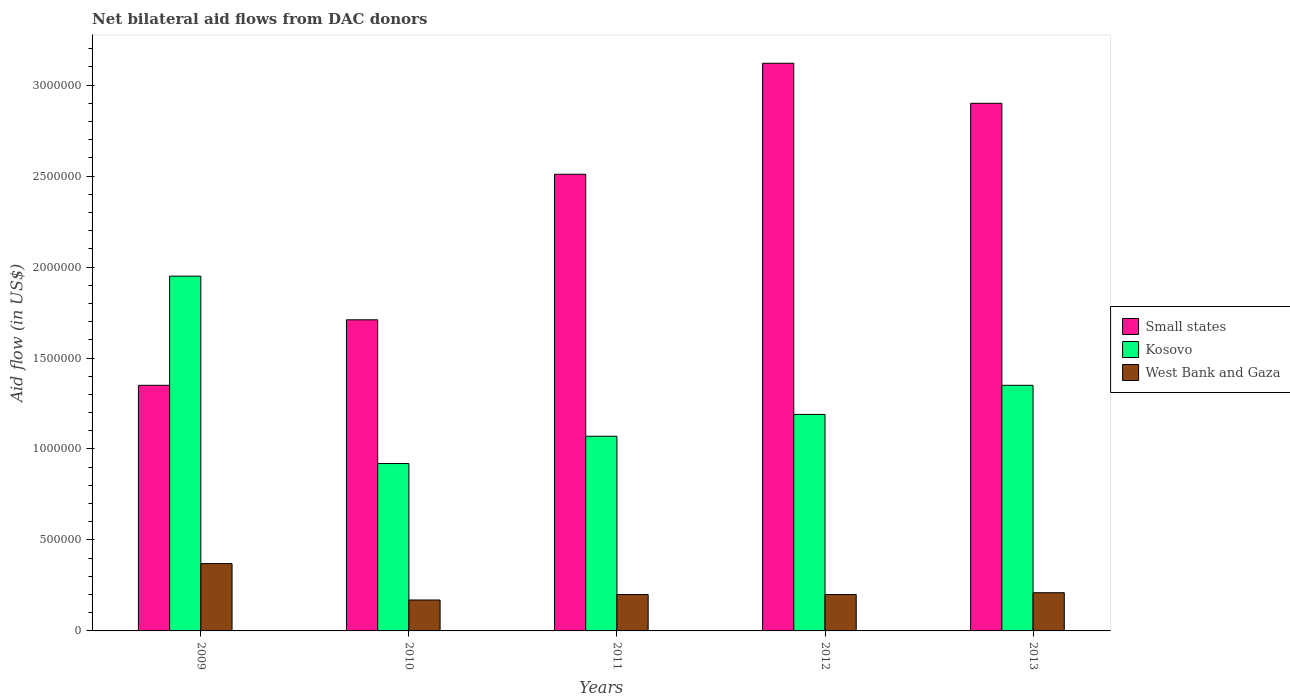How many groups of bars are there?
Your answer should be very brief. 5. Are the number of bars on each tick of the X-axis equal?
Provide a succinct answer. Yes. How many bars are there on the 1st tick from the left?
Offer a very short reply. 3. What is the label of the 5th group of bars from the left?
Provide a short and direct response. 2013. In how many cases, is the number of bars for a given year not equal to the number of legend labels?
Ensure brevity in your answer.  0. What is the net bilateral aid flow in Small states in 2010?
Provide a short and direct response. 1.71e+06. Across all years, what is the maximum net bilateral aid flow in Kosovo?
Give a very brief answer. 1.95e+06. Across all years, what is the minimum net bilateral aid flow in Kosovo?
Make the answer very short. 9.20e+05. What is the total net bilateral aid flow in Kosovo in the graph?
Make the answer very short. 6.48e+06. What is the difference between the net bilateral aid flow in Kosovo in 2012 and that in 2013?
Ensure brevity in your answer.  -1.60e+05. What is the difference between the net bilateral aid flow in Kosovo in 2011 and the net bilateral aid flow in Small states in 2012?
Provide a succinct answer. -2.05e+06. What is the average net bilateral aid flow in Kosovo per year?
Offer a terse response. 1.30e+06. In the year 2011, what is the difference between the net bilateral aid flow in West Bank and Gaza and net bilateral aid flow in Kosovo?
Provide a succinct answer. -8.70e+05. In how many years, is the net bilateral aid flow in West Bank and Gaza greater than 1100000 US$?
Offer a terse response. 0. What is the ratio of the net bilateral aid flow in West Bank and Gaza in 2009 to that in 2010?
Offer a terse response. 2.18. Is the net bilateral aid flow in Small states in 2011 less than that in 2012?
Provide a short and direct response. Yes. Is the difference between the net bilateral aid flow in West Bank and Gaza in 2009 and 2012 greater than the difference between the net bilateral aid flow in Kosovo in 2009 and 2012?
Keep it short and to the point. No. What is the difference between the highest and the second highest net bilateral aid flow in West Bank and Gaza?
Ensure brevity in your answer.  1.60e+05. What is the difference between the highest and the lowest net bilateral aid flow in Small states?
Your response must be concise. 1.77e+06. In how many years, is the net bilateral aid flow in Small states greater than the average net bilateral aid flow in Small states taken over all years?
Give a very brief answer. 3. Is the sum of the net bilateral aid flow in Kosovo in 2009 and 2011 greater than the maximum net bilateral aid flow in Small states across all years?
Offer a very short reply. No. What does the 2nd bar from the left in 2013 represents?
Your answer should be very brief. Kosovo. What does the 3rd bar from the right in 2011 represents?
Provide a short and direct response. Small states. Is it the case that in every year, the sum of the net bilateral aid flow in West Bank and Gaza and net bilateral aid flow in Kosovo is greater than the net bilateral aid flow in Small states?
Provide a short and direct response. No. Are all the bars in the graph horizontal?
Your response must be concise. No. Does the graph contain any zero values?
Provide a succinct answer. No. What is the title of the graph?
Provide a succinct answer. Net bilateral aid flows from DAC donors. What is the label or title of the Y-axis?
Offer a very short reply. Aid flow (in US$). What is the Aid flow (in US$) of Small states in 2009?
Ensure brevity in your answer.  1.35e+06. What is the Aid flow (in US$) of Kosovo in 2009?
Keep it short and to the point. 1.95e+06. What is the Aid flow (in US$) in Small states in 2010?
Provide a short and direct response. 1.71e+06. What is the Aid flow (in US$) in Kosovo in 2010?
Provide a succinct answer. 9.20e+05. What is the Aid flow (in US$) in West Bank and Gaza in 2010?
Give a very brief answer. 1.70e+05. What is the Aid flow (in US$) of Small states in 2011?
Your answer should be compact. 2.51e+06. What is the Aid flow (in US$) in Kosovo in 2011?
Keep it short and to the point. 1.07e+06. What is the Aid flow (in US$) in Small states in 2012?
Give a very brief answer. 3.12e+06. What is the Aid flow (in US$) of Kosovo in 2012?
Keep it short and to the point. 1.19e+06. What is the Aid flow (in US$) in Small states in 2013?
Provide a short and direct response. 2.90e+06. What is the Aid flow (in US$) in Kosovo in 2013?
Your response must be concise. 1.35e+06. Across all years, what is the maximum Aid flow (in US$) in Small states?
Provide a succinct answer. 3.12e+06. Across all years, what is the maximum Aid flow (in US$) in Kosovo?
Provide a short and direct response. 1.95e+06. Across all years, what is the minimum Aid flow (in US$) in Small states?
Keep it short and to the point. 1.35e+06. Across all years, what is the minimum Aid flow (in US$) in Kosovo?
Offer a terse response. 9.20e+05. What is the total Aid flow (in US$) in Small states in the graph?
Provide a short and direct response. 1.16e+07. What is the total Aid flow (in US$) in Kosovo in the graph?
Your answer should be compact. 6.48e+06. What is the total Aid flow (in US$) of West Bank and Gaza in the graph?
Your answer should be compact. 1.15e+06. What is the difference between the Aid flow (in US$) of Small states in 2009 and that in 2010?
Give a very brief answer. -3.60e+05. What is the difference between the Aid flow (in US$) of Kosovo in 2009 and that in 2010?
Ensure brevity in your answer.  1.03e+06. What is the difference between the Aid flow (in US$) of West Bank and Gaza in 2009 and that in 2010?
Ensure brevity in your answer.  2.00e+05. What is the difference between the Aid flow (in US$) of Small states in 2009 and that in 2011?
Give a very brief answer. -1.16e+06. What is the difference between the Aid flow (in US$) in Kosovo in 2009 and that in 2011?
Offer a terse response. 8.80e+05. What is the difference between the Aid flow (in US$) of West Bank and Gaza in 2009 and that in 2011?
Your response must be concise. 1.70e+05. What is the difference between the Aid flow (in US$) in Small states in 2009 and that in 2012?
Your answer should be very brief. -1.77e+06. What is the difference between the Aid flow (in US$) in Kosovo in 2009 and that in 2012?
Your answer should be compact. 7.60e+05. What is the difference between the Aid flow (in US$) of West Bank and Gaza in 2009 and that in 2012?
Provide a succinct answer. 1.70e+05. What is the difference between the Aid flow (in US$) of Small states in 2009 and that in 2013?
Make the answer very short. -1.55e+06. What is the difference between the Aid flow (in US$) of Kosovo in 2009 and that in 2013?
Offer a very short reply. 6.00e+05. What is the difference between the Aid flow (in US$) in West Bank and Gaza in 2009 and that in 2013?
Your response must be concise. 1.60e+05. What is the difference between the Aid flow (in US$) in Small states in 2010 and that in 2011?
Provide a succinct answer. -8.00e+05. What is the difference between the Aid flow (in US$) in West Bank and Gaza in 2010 and that in 2011?
Give a very brief answer. -3.00e+04. What is the difference between the Aid flow (in US$) in Small states in 2010 and that in 2012?
Your answer should be very brief. -1.41e+06. What is the difference between the Aid flow (in US$) of Kosovo in 2010 and that in 2012?
Give a very brief answer. -2.70e+05. What is the difference between the Aid flow (in US$) of West Bank and Gaza in 2010 and that in 2012?
Offer a very short reply. -3.00e+04. What is the difference between the Aid flow (in US$) in Small states in 2010 and that in 2013?
Your answer should be very brief. -1.19e+06. What is the difference between the Aid flow (in US$) of Kosovo in 2010 and that in 2013?
Provide a short and direct response. -4.30e+05. What is the difference between the Aid flow (in US$) in West Bank and Gaza in 2010 and that in 2013?
Offer a terse response. -4.00e+04. What is the difference between the Aid flow (in US$) of Small states in 2011 and that in 2012?
Your answer should be compact. -6.10e+05. What is the difference between the Aid flow (in US$) in Kosovo in 2011 and that in 2012?
Give a very brief answer. -1.20e+05. What is the difference between the Aid flow (in US$) of West Bank and Gaza in 2011 and that in 2012?
Your answer should be very brief. 0. What is the difference between the Aid flow (in US$) in Small states in 2011 and that in 2013?
Keep it short and to the point. -3.90e+05. What is the difference between the Aid flow (in US$) of Kosovo in 2011 and that in 2013?
Give a very brief answer. -2.80e+05. What is the difference between the Aid flow (in US$) of West Bank and Gaza in 2011 and that in 2013?
Offer a very short reply. -10000. What is the difference between the Aid flow (in US$) in Kosovo in 2012 and that in 2013?
Keep it short and to the point. -1.60e+05. What is the difference between the Aid flow (in US$) of West Bank and Gaza in 2012 and that in 2013?
Provide a short and direct response. -10000. What is the difference between the Aid flow (in US$) of Small states in 2009 and the Aid flow (in US$) of Kosovo in 2010?
Make the answer very short. 4.30e+05. What is the difference between the Aid flow (in US$) in Small states in 2009 and the Aid flow (in US$) in West Bank and Gaza in 2010?
Offer a very short reply. 1.18e+06. What is the difference between the Aid flow (in US$) in Kosovo in 2009 and the Aid flow (in US$) in West Bank and Gaza in 2010?
Make the answer very short. 1.78e+06. What is the difference between the Aid flow (in US$) in Small states in 2009 and the Aid flow (in US$) in West Bank and Gaza in 2011?
Provide a succinct answer. 1.15e+06. What is the difference between the Aid flow (in US$) of Kosovo in 2009 and the Aid flow (in US$) of West Bank and Gaza in 2011?
Offer a terse response. 1.75e+06. What is the difference between the Aid flow (in US$) of Small states in 2009 and the Aid flow (in US$) of Kosovo in 2012?
Your answer should be very brief. 1.60e+05. What is the difference between the Aid flow (in US$) of Small states in 2009 and the Aid flow (in US$) of West Bank and Gaza in 2012?
Provide a succinct answer. 1.15e+06. What is the difference between the Aid flow (in US$) in Kosovo in 2009 and the Aid flow (in US$) in West Bank and Gaza in 2012?
Offer a terse response. 1.75e+06. What is the difference between the Aid flow (in US$) in Small states in 2009 and the Aid flow (in US$) in Kosovo in 2013?
Give a very brief answer. 0. What is the difference between the Aid flow (in US$) of Small states in 2009 and the Aid flow (in US$) of West Bank and Gaza in 2013?
Offer a very short reply. 1.14e+06. What is the difference between the Aid flow (in US$) in Kosovo in 2009 and the Aid flow (in US$) in West Bank and Gaza in 2013?
Give a very brief answer. 1.74e+06. What is the difference between the Aid flow (in US$) in Small states in 2010 and the Aid flow (in US$) in Kosovo in 2011?
Provide a succinct answer. 6.40e+05. What is the difference between the Aid flow (in US$) of Small states in 2010 and the Aid flow (in US$) of West Bank and Gaza in 2011?
Make the answer very short. 1.51e+06. What is the difference between the Aid flow (in US$) of Kosovo in 2010 and the Aid flow (in US$) of West Bank and Gaza in 2011?
Provide a succinct answer. 7.20e+05. What is the difference between the Aid flow (in US$) of Small states in 2010 and the Aid flow (in US$) of Kosovo in 2012?
Make the answer very short. 5.20e+05. What is the difference between the Aid flow (in US$) of Small states in 2010 and the Aid flow (in US$) of West Bank and Gaza in 2012?
Offer a terse response. 1.51e+06. What is the difference between the Aid flow (in US$) of Kosovo in 2010 and the Aid flow (in US$) of West Bank and Gaza in 2012?
Your answer should be very brief. 7.20e+05. What is the difference between the Aid flow (in US$) of Small states in 2010 and the Aid flow (in US$) of West Bank and Gaza in 2013?
Ensure brevity in your answer.  1.50e+06. What is the difference between the Aid flow (in US$) in Kosovo in 2010 and the Aid flow (in US$) in West Bank and Gaza in 2013?
Give a very brief answer. 7.10e+05. What is the difference between the Aid flow (in US$) in Small states in 2011 and the Aid flow (in US$) in Kosovo in 2012?
Your answer should be compact. 1.32e+06. What is the difference between the Aid flow (in US$) of Small states in 2011 and the Aid flow (in US$) of West Bank and Gaza in 2012?
Your response must be concise. 2.31e+06. What is the difference between the Aid flow (in US$) in Kosovo in 2011 and the Aid flow (in US$) in West Bank and Gaza in 2012?
Your answer should be very brief. 8.70e+05. What is the difference between the Aid flow (in US$) in Small states in 2011 and the Aid flow (in US$) in Kosovo in 2013?
Provide a short and direct response. 1.16e+06. What is the difference between the Aid flow (in US$) in Small states in 2011 and the Aid flow (in US$) in West Bank and Gaza in 2013?
Keep it short and to the point. 2.30e+06. What is the difference between the Aid flow (in US$) in Kosovo in 2011 and the Aid flow (in US$) in West Bank and Gaza in 2013?
Make the answer very short. 8.60e+05. What is the difference between the Aid flow (in US$) in Small states in 2012 and the Aid flow (in US$) in Kosovo in 2013?
Offer a terse response. 1.77e+06. What is the difference between the Aid flow (in US$) in Small states in 2012 and the Aid flow (in US$) in West Bank and Gaza in 2013?
Ensure brevity in your answer.  2.91e+06. What is the difference between the Aid flow (in US$) in Kosovo in 2012 and the Aid flow (in US$) in West Bank and Gaza in 2013?
Your response must be concise. 9.80e+05. What is the average Aid flow (in US$) in Small states per year?
Give a very brief answer. 2.32e+06. What is the average Aid flow (in US$) of Kosovo per year?
Make the answer very short. 1.30e+06. What is the average Aid flow (in US$) of West Bank and Gaza per year?
Your answer should be very brief. 2.30e+05. In the year 2009, what is the difference between the Aid flow (in US$) in Small states and Aid flow (in US$) in Kosovo?
Provide a short and direct response. -6.00e+05. In the year 2009, what is the difference between the Aid flow (in US$) in Small states and Aid flow (in US$) in West Bank and Gaza?
Your response must be concise. 9.80e+05. In the year 2009, what is the difference between the Aid flow (in US$) in Kosovo and Aid flow (in US$) in West Bank and Gaza?
Give a very brief answer. 1.58e+06. In the year 2010, what is the difference between the Aid flow (in US$) of Small states and Aid flow (in US$) of Kosovo?
Provide a short and direct response. 7.90e+05. In the year 2010, what is the difference between the Aid flow (in US$) of Small states and Aid flow (in US$) of West Bank and Gaza?
Ensure brevity in your answer.  1.54e+06. In the year 2010, what is the difference between the Aid flow (in US$) in Kosovo and Aid flow (in US$) in West Bank and Gaza?
Your answer should be very brief. 7.50e+05. In the year 2011, what is the difference between the Aid flow (in US$) of Small states and Aid flow (in US$) of Kosovo?
Your answer should be very brief. 1.44e+06. In the year 2011, what is the difference between the Aid flow (in US$) in Small states and Aid flow (in US$) in West Bank and Gaza?
Ensure brevity in your answer.  2.31e+06. In the year 2011, what is the difference between the Aid flow (in US$) in Kosovo and Aid flow (in US$) in West Bank and Gaza?
Your answer should be very brief. 8.70e+05. In the year 2012, what is the difference between the Aid flow (in US$) in Small states and Aid flow (in US$) in Kosovo?
Provide a short and direct response. 1.93e+06. In the year 2012, what is the difference between the Aid flow (in US$) in Small states and Aid flow (in US$) in West Bank and Gaza?
Provide a succinct answer. 2.92e+06. In the year 2012, what is the difference between the Aid flow (in US$) in Kosovo and Aid flow (in US$) in West Bank and Gaza?
Your answer should be very brief. 9.90e+05. In the year 2013, what is the difference between the Aid flow (in US$) in Small states and Aid flow (in US$) in Kosovo?
Give a very brief answer. 1.55e+06. In the year 2013, what is the difference between the Aid flow (in US$) in Small states and Aid flow (in US$) in West Bank and Gaza?
Offer a terse response. 2.69e+06. In the year 2013, what is the difference between the Aid flow (in US$) in Kosovo and Aid flow (in US$) in West Bank and Gaza?
Offer a very short reply. 1.14e+06. What is the ratio of the Aid flow (in US$) of Small states in 2009 to that in 2010?
Provide a short and direct response. 0.79. What is the ratio of the Aid flow (in US$) in Kosovo in 2009 to that in 2010?
Keep it short and to the point. 2.12. What is the ratio of the Aid flow (in US$) of West Bank and Gaza in 2009 to that in 2010?
Your response must be concise. 2.18. What is the ratio of the Aid flow (in US$) in Small states in 2009 to that in 2011?
Offer a very short reply. 0.54. What is the ratio of the Aid flow (in US$) in Kosovo in 2009 to that in 2011?
Offer a terse response. 1.82. What is the ratio of the Aid flow (in US$) in West Bank and Gaza in 2009 to that in 2011?
Provide a short and direct response. 1.85. What is the ratio of the Aid flow (in US$) of Small states in 2009 to that in 2012?
Offer a terse response. 0.43. What is the ratio of the Aid flow (in US$) of Kosovo in 2009 to that in 2012?
Provide a succinct answer. 1.64. What is the ratio of the Aid flow (in US$) of West Bank and Gaza in 2009 to that in 2012?
Ensure brevity in your answer.  1.85. What is the ratio of the Aid flow (in US$) of Small states in 2009 to that in 2013?
Provide a short and direct response. 0.47. What is the ratio of the Aid flow (in US$) in Kosovo in 2009 to that in 2013?
Offer a very short reply. 1.44. What is the ratio of the Aid flow (in US$) of West Bank and Gaza in 2009 to that in 2013?
Ensure brevity in your answer.  1.76. What is the ratio of the Aid flow (in US$) in Small states in 2010 to that in 2011?
Your answer should be very brief. 0.68. What is the ratio of the Aid flow (in US$) in Kosovo in 2010 to that in 2011?
Ensure brevity in your answer.  0.86. What is the ratio of the Aid flow (in US$) in Small states in 2010 to that in 2012?
Offer a terse response. 0.55. What is the ratio of the Aid flow (in US$) of Kosovo in 2010 to that in 2012?
Provide a short and direct response. 0.77. What is the ratio of the Aid flow (in US$) of Small states in 2010 to that in 2013?
Keep it short and to the point. 0.59. What is the ratio of the Aid flow (in US$) in Kosovo in 2010 to that in 2013?
Offer a terse response. 0.68. What is the ratio of the Aid flow (in US$) of West Bank and Gaza in 2010 to that in 2013?
Keep it short and to the point. 0.81. What is the ratio of the Aid flow (in US$) of Small states in 2011 to that in 2012?
Your answer should be very brief. 0.8. What is the ratio of the Aid flow (in US$) in Kosovo in 2011 to that in 2012?
Ensure brevity in your answer.  0.9. What is the ratio of the Aid flow (in US$) in West Bank and Gaza in 2011 to that in 2012?
Provide a short and direct response. 1. What is the ratio of the Aid flow (in US$) in Small states in 2011 to that in 2013?
Your answer should be compact. 0.87. What is the ratio of the Aid flow (in US$) in Kosovo in 2011 to that in 2013?
Provide a succinct answer. 0.79. What is the ratio of the Aid flow (in US$) in West Bank and Gaza in 2011 to that in 2013?
Offer a very short reply. 0.95. What is the ratio of the Aid flow (in US$) in Small states in 2012 to that in 2013?
Keep it short and to the point. 1.08. What is the ratio of the Aid flow (in US$) of Kosovo in 2012 to that in 2013?
Your response must be concise. 0.88. What is the difference between the highest and the second highest Aid flow (in US$) in Small states?
Your answer should be compact. 2.20e+05. What is the difference between the highest and the second highest Aid flow (in US$) of West Bank and Gaza?
Make the answer very short. 1.60e+05. What is the difference between the highest and the lowest Aid flow (in US$) in Small states?
Make the answer very short. 1.77e+06. What is the difference between the highest and the lowest Aid flow (in US$) in Kosovo?
Your answer should be very brief. 1.03e+06. 